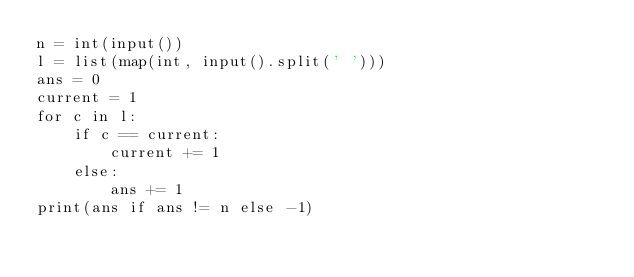Convert code to text. <code><loc_0><loc_0><loc_500><loc_500><_Python_>n = int(input())
l = list(map(int, input().split(' ')))
ans = 0
current = 1
for c in l:
    if c == current:
        current += 1
    else:
        ans += 1
print(ans if ans != n else -1)
    </code> 